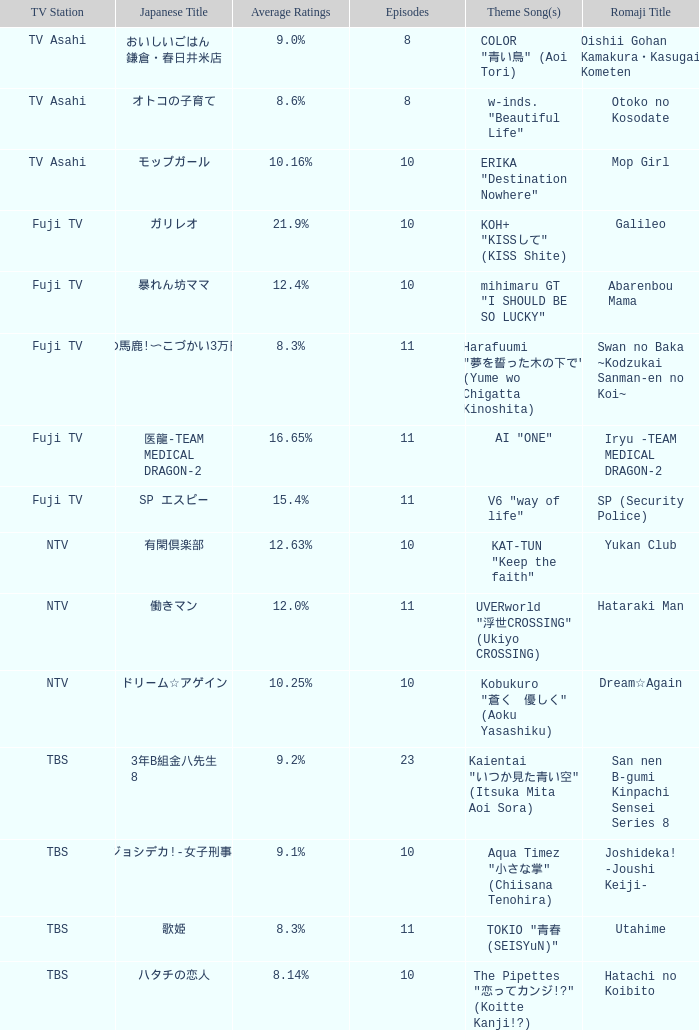What is the Theme Song of Iryu -Team Medical Dragon-2? AI "ONE". 